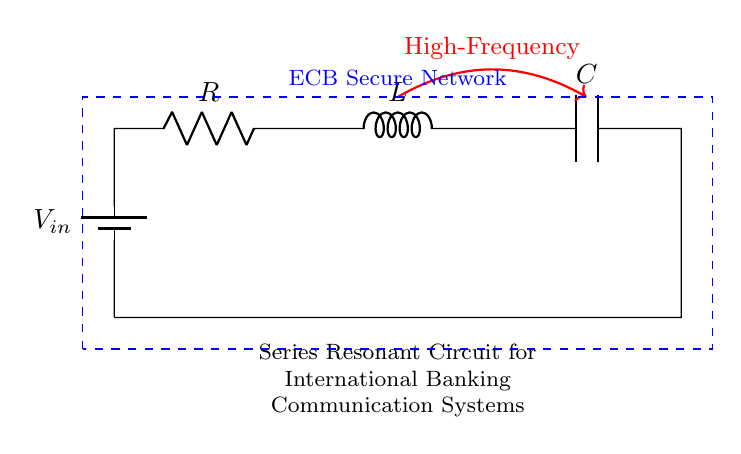What type of circuit is depicted? The circuit is a series resonant circuit, which is identified by the arrangement of components in series including a resistor, inductor, and capacitor.
Answer: series resonant circuit What is the purpose of the inductor in this circuit? The inductor stores energy in its magnetic field and contributes to the resonant frequency when combined with the resistor and capacitor. Its presence indicates it plays a crucial role in determining the behavior at high frequencies.
Answer: energy storage What are the components present in the circuit? The components include a resistor, inductor, capacitor, and a voltage source; these are clearly labeled in the diagram representing a series resonant circuit.
Answer: resistor, inductor, capacitor, voltage source What is the significance of high frequency in this circuit? High frequency is essential in the context of communication systems, as it allows for efficient signal transmission in international banking networks, ensuring faster data transfer and communication reliability.
Answer: efficient communication How is the capacitor connected in the circuit? The capacitor is connected in series with the resistor and inductor, completing the loop back to the voltage source, which is characteristic of a series connection in resonant circuits.
Answer: in series What key term describes the function of this circuit in banking networks? This circuit functions as a communication system, facilitating the transmission of high-frequency signals, which is critical for secure banking transactions across international networks.
Answer: communication system What is indicated by the label "ECB Secure Network"? The label denotes that this circuit is part of a secure communication infrastructure for the European Central Bank, emphasizing the importance of security in monetary policy activities.
Answer: secure communication infrastructure 